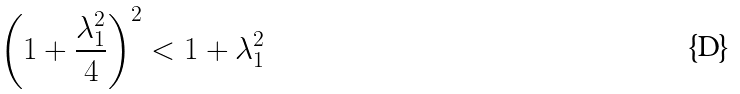<formula> <loc_0><loc_0><loc_500><loc_500>\left ( 1 + \frac { \lambda _ { 1 } ^ { 2 } } { 4 } \right ) ^ { 2 } < 1 + \lambda _ { 1 } ^ { 2 }</formula> 